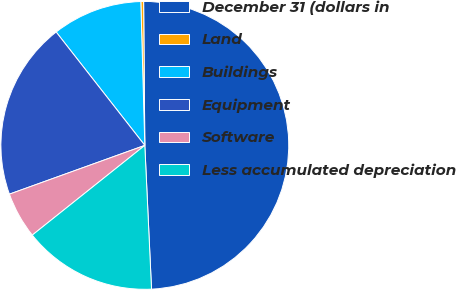Convert chart to OTSL. <chart><loc_0><loc_0><loc_500><loc_500><pie_chart><fcel>December 31 (dollars in<fcel>Land<fcel>Buildings<fcel>Equipment<fcel>Software<fcel>Less accumulated depreciation<nl><fcel>49.39%<fcel>0.31%<fcel>10.12%<fcel>19.94%<fcel>5.21%<fcel>15.03%<nl></chart> 